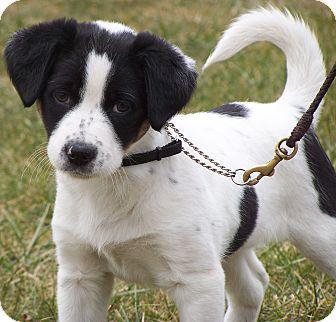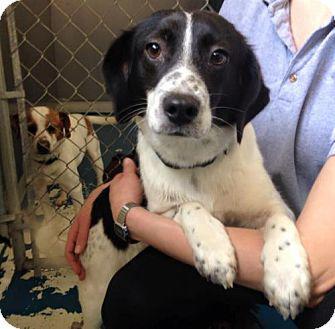The first image is the image on the left, the second image is the image on the right. Analyze the images presented: Is the assertion "An image includes a standing dog with its tail upright and curved inward." valid? Answer yes or no. Yes. The first image is the image on the left, the second image is the image on the right. For the images displayed, is the sentence "One dog in the image on the left is standing up on all fours." factually correct? Answer yes or no. Yes. 